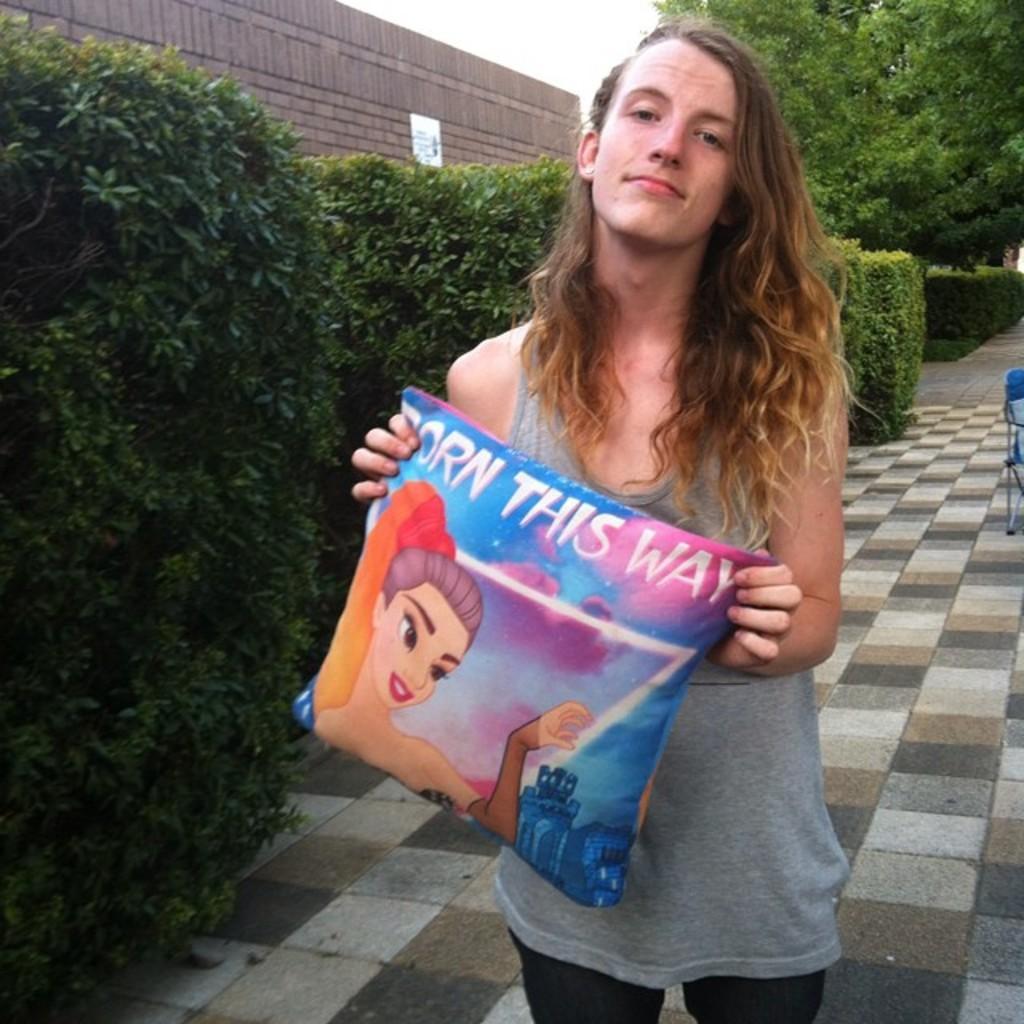Could you give a brief overview of what you see in this image? In the image there is a woman, she is holding a pillow in her hand and on the left side there are many plants. The woman is standing on a pavement. 